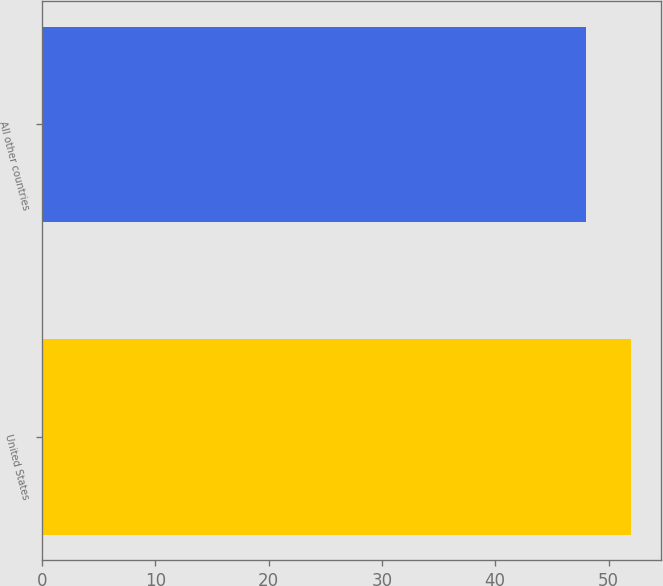Convert chart. <chart><loc_0><loc_0><loc_500><loc_500><bar_chart><fcel>United States<fcel>All other countries<nl><fcel>52<fcel>48<nl></chart> 